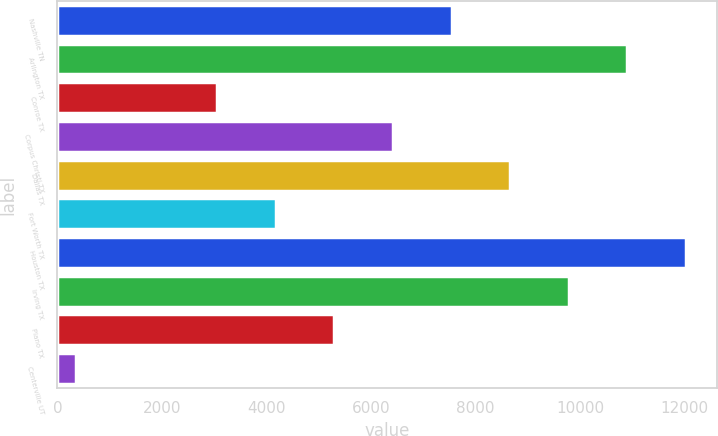Convert chart to OTSL. <chart><loc_0><loc_0><loc_500><loc_500><bar_chart><fcel>Nashville TN<fcel>Arlington TX<fcel>Conroe TX<fcel>Corpus Christi TX<fcel>Dallas TX<fcel>Fort Worth TX<fcel>Houston TX<fcel>Irving TX<fcel>Plano TX<fcel>Centerville UT<nl><fcel>7539.8<fcel>10900.4<fcel>3059<fcel>6419.6<fcel>8660<fcel>4179.2<fcel>12020.6<fcel>9780.2<fcel>5299.4<fcel>348<nl></chart> 